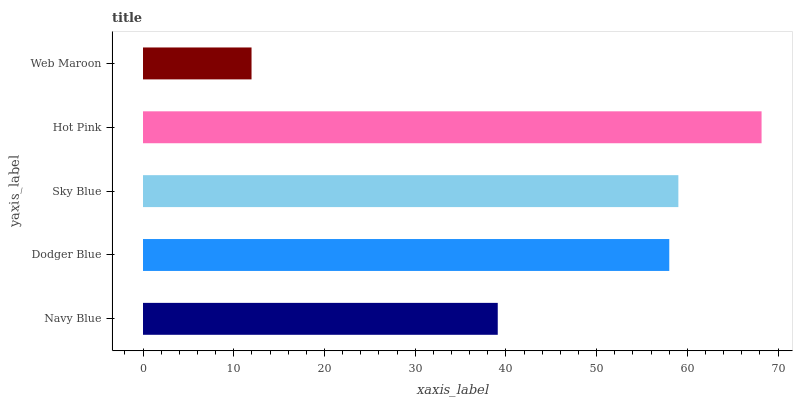Is Web Maroon the minimum?
Answer yes or no. Yes. Is Hot Pink the maximum?
Answer yes or no. Yes. Is Dodger Blue the minimum?
Answer yes or no. No. Is Dodger Blue the maximum?
Answer yes or no. No. Is Dodger Blue greater than Navy Blue?
Answer yes or no. Yes. Is Navy Blue less than Dodger Blue?
Answer yes or no. Yes. Is Navy Blue greater than Dodger Blue?
Answer yes or no. No. Is Dodger Blue less than Navy Blue?
Answer yes or no. No. Is Dodger Blue the high median?
Answer yes or no. Yes. Is Dodger Blue the low median?
Answer yes or no. Yes. Is Web Maroon the high median?
Answer yes or no. No. Is Sky Blue the low median?
Answer yes or no. No. 